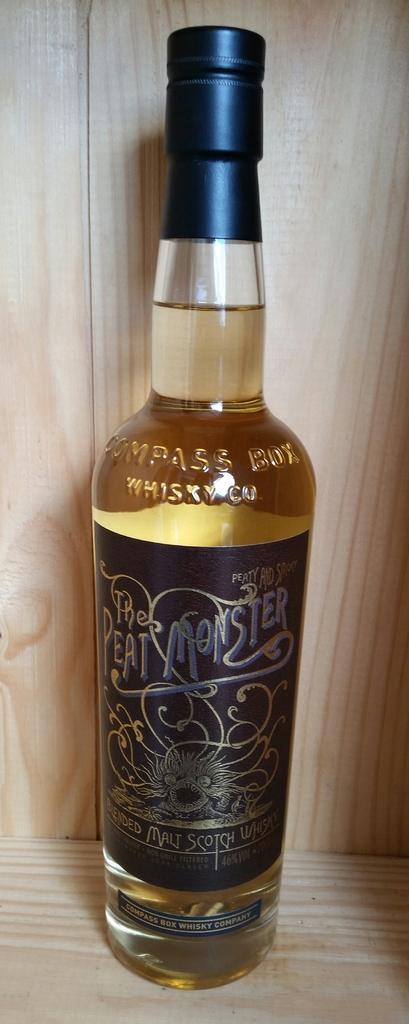Provide a one-sentence caption for the provided image. A bottle labelled Peat Monster full of a yellowish liquid. 